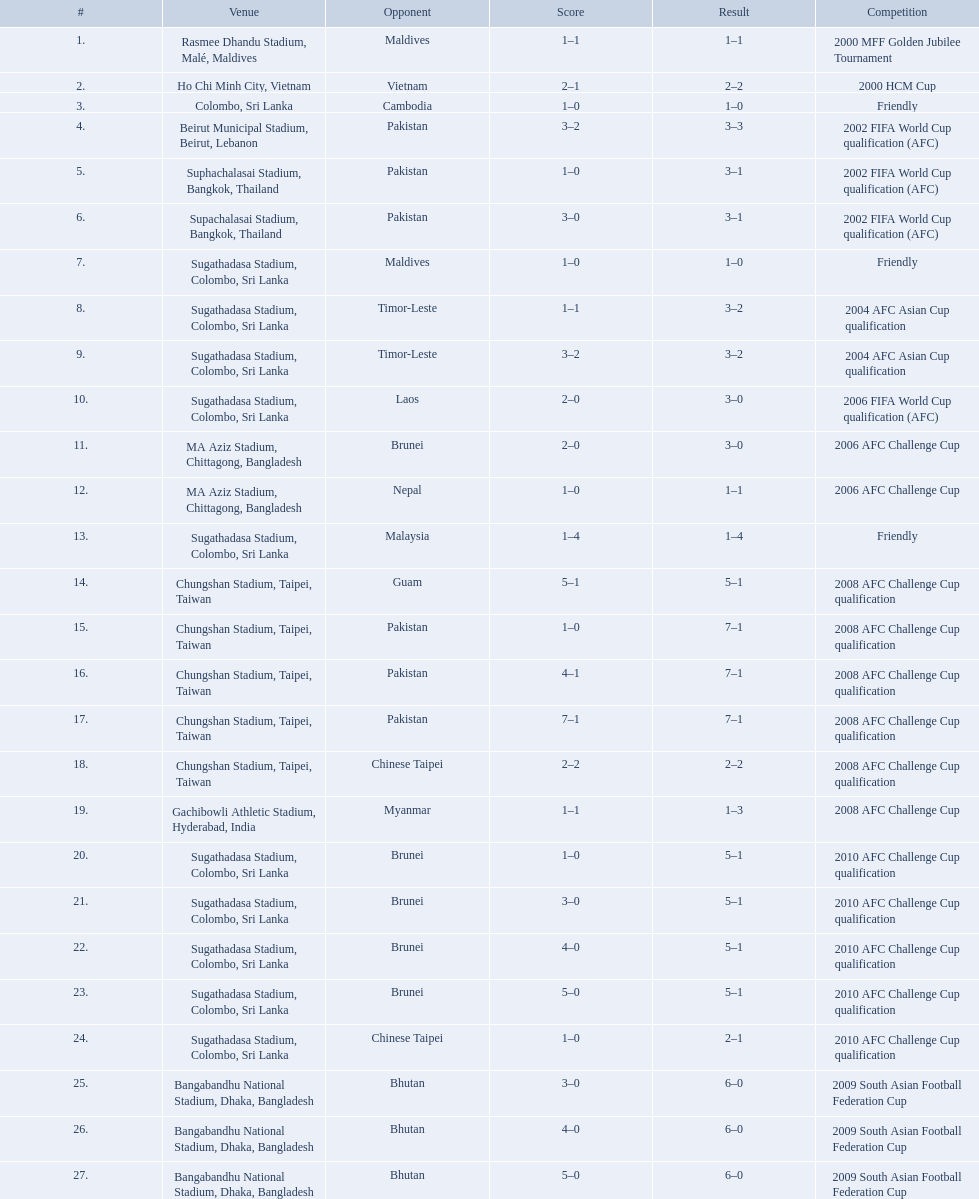How many venues are in the table? 27. Which one is the top listed? Rasmee Dhandu Stadium, Malé, Maldives. What venues are listed? Rasmee Dhandu Stadium, Malé, Maldives, Ho Chi Minh City, Vietnam, Colombo, Sri Lanka, Beirut Municipal Stadium, Beirut, Lebanon, Suphachalasai Stadium, Bangkok, Thailand, MA Aziz Stadium, Chittagong, Bangladesh, Sugathadasa Stadium, Colombo, Sri Lanka, Chungshan Stadium, Taipei, Taiwan, Gachibowli Athletic Stadium, Hyderabad, India, Sugathadasa Stadium, Colombo, Sri Lanka, Bangabandhu National Stadium, Dhaka, Bangladesh. Which is top listed? Rasmee Dhandu Stadium, Malé, Maldives. 